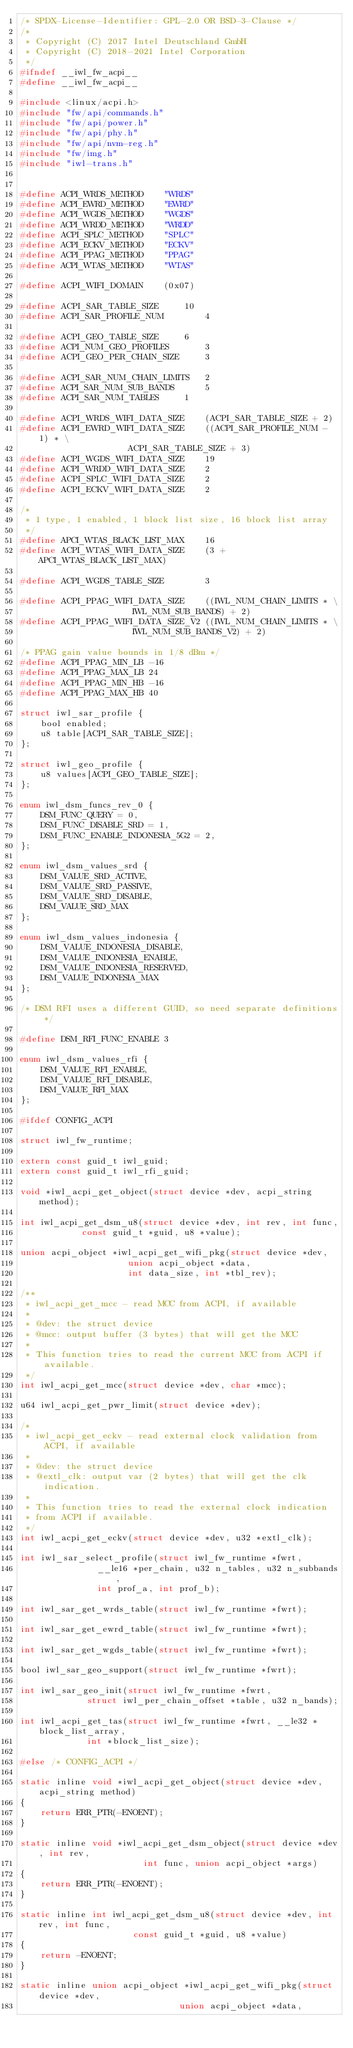Convert code to text. <code><loc_0><loc_0><loc_500><loc_500><_C_>/* SPDX-License-Identifier: GPL-2.0 OR BSD-3-Clause */
/*
 * Copyright (C) 2017 Intel Deutschland GmbH
 * Copyright (C) 2018-2021 Intel Corporation
 */
#ifndef __iwl_fw_acpi__
#define __iwl_fw_acpi__

#include <linux/acpi.h>
#include "fw/api/commands.h"
#include "fw/api/power.h"
#include "fw/api/phy.h"
#include "fw/api/nvm-reg.h"
#include "fw/img.h"
#include "iwl-trans.h"


#define ACPI_WRDS_METHOD	"WRDS"
#define ACPI_EWRD_METHOD	"EWRD"
#define ACPI_WGDS_METHOD	"WGDS"
#define ACPI_WRDD_METHOD	"WRDD"
#define ACPI_SPLC_METHOD	"SPLC"
#define ACPI_ECKV_METHOD	"ECKV"
#define ACPI_PPAG_METHOD	"PPAG"
#define ACPI_WTAS_METHOD	"WTAS"

#define ACPI_WIFI_DOMAIN	(0x07)

#define ACPI_SAR_TABLE_SIZE		10
#define ACPI_SAR_PROFILE_NUM		4

#define ACPI_GEO_TABLE_SIZE		6
#define ACPI_NUM_GEO_PROFILES		3
#define ACPI_GEO_PER_CHAIN_SIZE		3

#define ACPI_SAR_NUM_CHAIN_LIMITS	2
#define ACPI_SAR_NUM_SUB_BANDS		5
#define ACPI_SAR_NUM_TABLES		1

#define ACPI_WRDS_WIFI_DATA_SIZE	(ACPI_SAR_TABLE_SIZE + 2)
#define ACPI_EWRD_WIFI_DATA_SIZE	((ACPI_SAR_PROFILE_NUM - 1) * \
					 ACPI_SAR_TABLE_SIZE + 3)
#define ACPI_WGDS_WIFI_DATA_SIZE	19
#define ACPI_WRDD_WIFI_DATA_SIZE	2
#define ACPI_SPLC_WIFI_DATA_SIZE	2
#define ACPI_ECKV_WIFI_DATA_SIZE	2

/*
 * 1 type, 1 enabled, 1 block list size, 16 block list array
 */
#define APCI_WTAS_BLACK_LIST_MAX	16
#define ACPI_WTAS_WIFI_DATA_SIZE	(3 + APCI_WTAS_BLACK_LIST_MAX)

#define ACPI_WGDS_TABLE_SIZE		3

#define ACPI_PPAG_WIFI_DATA_SIZE	((IWL_NUM_CHAIN_LIMITS * \
					  IWL_NUM_SUB_BANDS) + 2)
#define ACPI_PPAG_WIFI_DATA_SIZE_V2	((IWL_NUM_CHAIN_LIMITS * \
					  IWL_NUM_SUB_BANDS_V2) + 2)

/* PPAG gain value bounds in 1/8 dBm */
#define ACPI_PPAG_MIN_LB -16
#define ACPI_PPAG_MAX_LB 24
#define ACPI_PPAG_MIN_HB -16
#define ACPI_PPAG_MAX_HB 40

struct iwl_sar_profile {
	bool enabled;
	u8 table[ACPI_SAR_TABLE_SIZE];
};

struct iwl_geo_profile {
	u8 values[ACPI_GEO_TABLE_SIZE];
};

enum iwl_dsm_funcs_rev_0 {
	DSM_FUNC_QUERY = 0,
	DSM_FUNC_DISABLE_SRD = 1,
	DSM_FUNC_ENABLE_INDONESIA_5G2 = 2,
};

enum iwl_dsm_values_srd {
	DSM_VALUE_SRD_ACTIVE,
	DSM_VALUE_SRD_PASSIVE,
	DSM_VALUE_SRD_DISABLE,
	DSM_VALUE_SRD_MAX
};

enum iwl_dsm_values_indonesia {
	DSM_VALUE_INDONESIA_DISABLE,
	DSM_VALUE_INDONESIA_ENABLE,
	DSM_VALUE_INDONESIA_RESERVED,
	DSM_VALUE_INDONESIA_MAX
};

/* DSM RFI uses a different GUID, so need separate definitions */

#define DSM_RFI_FUNC_ENABLE 3

enum iwl_dsm_values_rfi {
	DSM_VALUE_RFI_ENABLE,
	DSM_VALUE_RFI_DISABLE,
	DSM_VALUE_RFI_MAX
};

#ifdef CONFIG_ACPI

struct iwl_fw_runtime;

extern const guid_t iwl_guid;
extern const guid_t iwl_rfi_guid;

void *iwl_acpi_get_object(struct device *dev, acpi_string method);

int iwl_acpi_get_dsm_u8(struct device *dev, int rev, int func,
			const guid_t *guid, u8 *value);

union acpi_object *iwl_acpi_get_wifi_pkg(struct device *dev,
					 union acpi_object *data,
					 int data_size, int *tbl_rev);

/**
 * iwl_acpi_get_mcc - read MCC from ACPI, if available
 *
 * @dev: the struct device
 * @mcc: output buffer (3 bytes) that will get the MCC
 *
 * This function tries to read the current MCC from ACPI if available.
 */
int iwl_acpi_get_mcc(struct device *dev, char *mcc);

u64 iwl_acpi_get_pwr_limit(struct device *dev);

/*
 * iwl_acpi_get_eckv - read external clock validation from ACPI, if available
 *
 * @dev: the struct device
 * @extl_clk: output var (2 bytes) that will get the clk indication.
 *
 * This function tries to read the external clock indication
 * from ACPI if available.
 */
int iwl_acpi_get_eckv(struct device *dev, u32 *extl_clk);

int iwl_sar_select_profile(struct iwl_fw_runtime *fwrt,
			   __le16 *per_chain, u32 n_tables, u32 n_subbands,
			   int prof_a, int prof_b);

int iwl_sar_get_wrds_table(struct iwl_fw_runtime *fwrt);

int iwl_sar_get_ewrd_table(struct iwl_fw_runtime *fwrt);

int iwl_sar_get_wgds_table(struct iwl_fw_runtime *fwrt);

bool iwl_sar_geo_support(struct iwl_fw_runtime *fwrt);

int iwl_sar_geo_init(struct iwl_fw_runtime *fwrt,
		     struct iwl_per_chain_offset *table, u32 n_bands);

int iwl_acpi_get_tas(struct iwl_fw_runtime *fwrt, __le32 *block_list_array,
		     int *block_list_size);

#else /* CONFIG_ACPI */

static inline void *iwl_acpi_get_object(struct device *dev, acpi_string method)
{
	return ERR_PTR(-ENOENT);
}

static inline void *iwl_acpi_get_dsm_object(struct device *dev, int rev,
					    int func, union acpi_object *args)
{
	return ERR_PTR(-ENOENT);
}

static inline int iwl_acpi_get_dsm_u8(struct device *dev, int rev, int func,
				      const guid_t *guid, u8 *value)
{
	return -ENOENT;
}

static inline union acpi_object *iwl_acpi_get_wifi_pkg(struct device *dev,
						       union acpi_object *data,</code> 